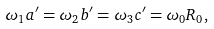Convert formula to latex. <formula><loc_0><loc_0><loc_500><loc_500>\omega _ { 1 } a ^ { \prime } = \omega _ { 2 } b ^ { \prime } = \omega _ { 3 } c ^ { \prime } = \omega _ { 0 } R _ { 0 } ,</formula> 